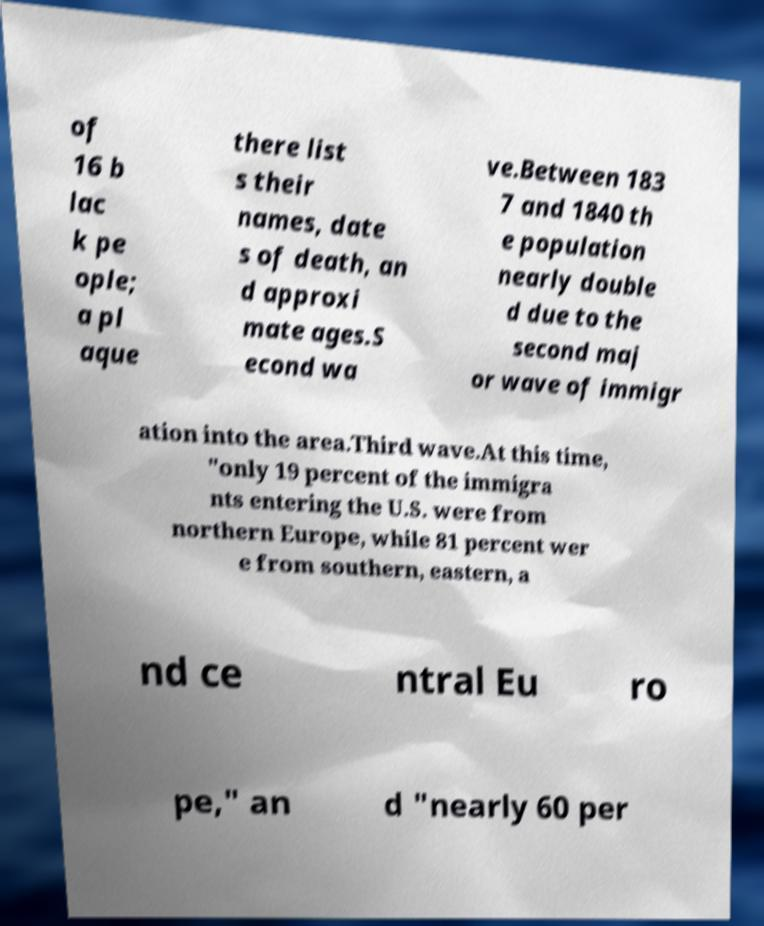Please read and relay the text visible in this image. What does it say? of 16 b lac k pe ople; a pl aque there list s their names, date s of death, an d approxi mate ages.S econd wa ve.Between 183 7 and 1840 th e population nearly double d due to the second maj or wave of immigr ation into the area.Third wave.At this time, "only 19 percent of the immigra nts entering the U.S. were from northern Europe, while 81 percent wer e from southern, eastern, a nd ce ntral Eu ro pe," an d "nearly 60 per 